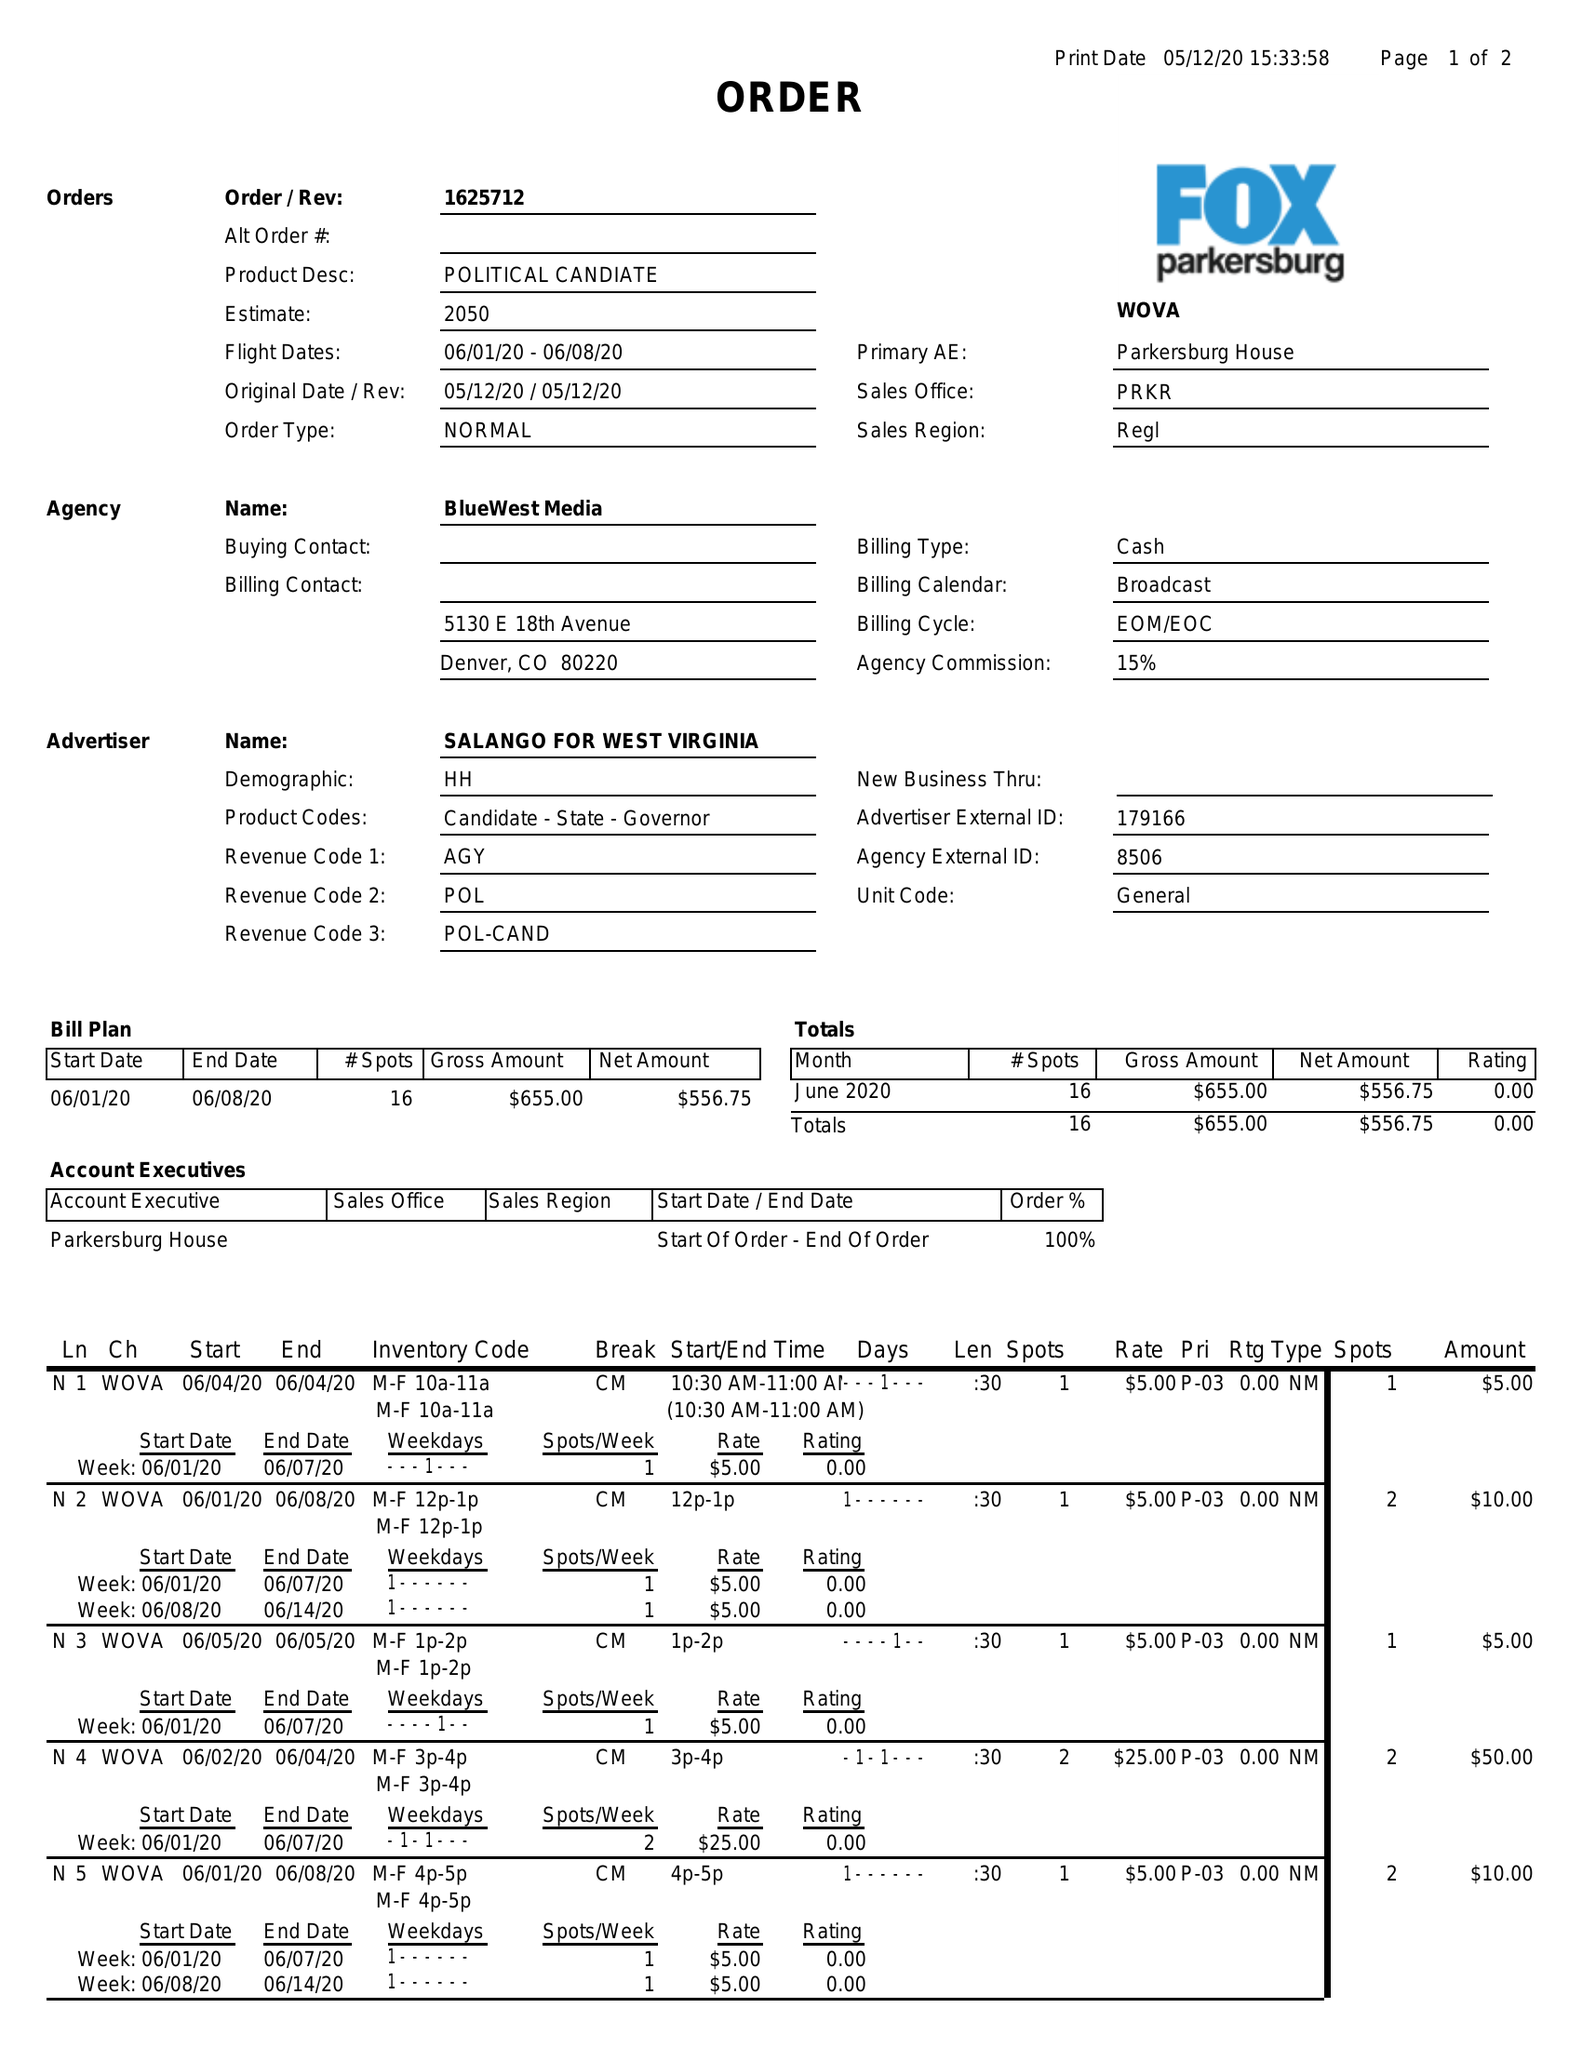What is the value for the flight_from?
Answer the question using a single word or phrase. 06/01/20 